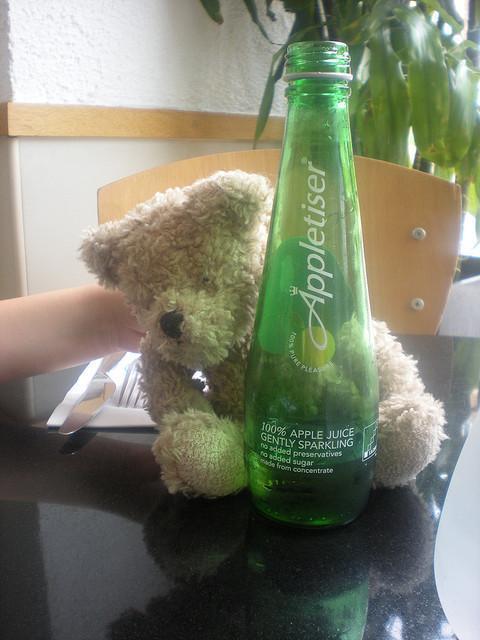Verify the accuracy of this image caption: "The teddy bear is touching the potted plant.".
Answer yes or no. No. Does the caption "The teddy bear is away from the dining table." correctly depict the image?
Answer yes or no. No. Is the statement "The dining table is in front of the teddy bear." accurate regarding the image?
Answer yes or no. No. Is this affirmation: "The bottle is touching the teddy bear." correct?
Answer yes or no. Yes. Does the description: "The potted plant is in front of the teddy bear." accurately reflect the image?
Answer yes or no. No. Evaluate: Does the caption "The dining table is touching the teddy bear." match the image?
Answer yes or no. Yes. Is the caption "The teddy bear is on top of the dining table." a true representation of the image?
Answer yes or no. Yes. 